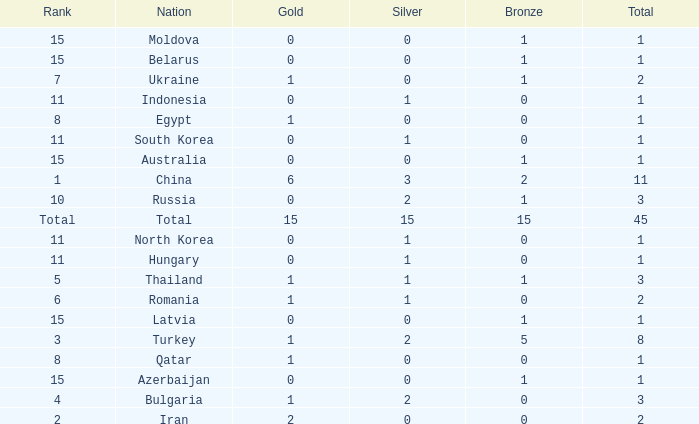What is the highest amount of bronze china, which has more than 1 gold and more than 11 total, has? None. 